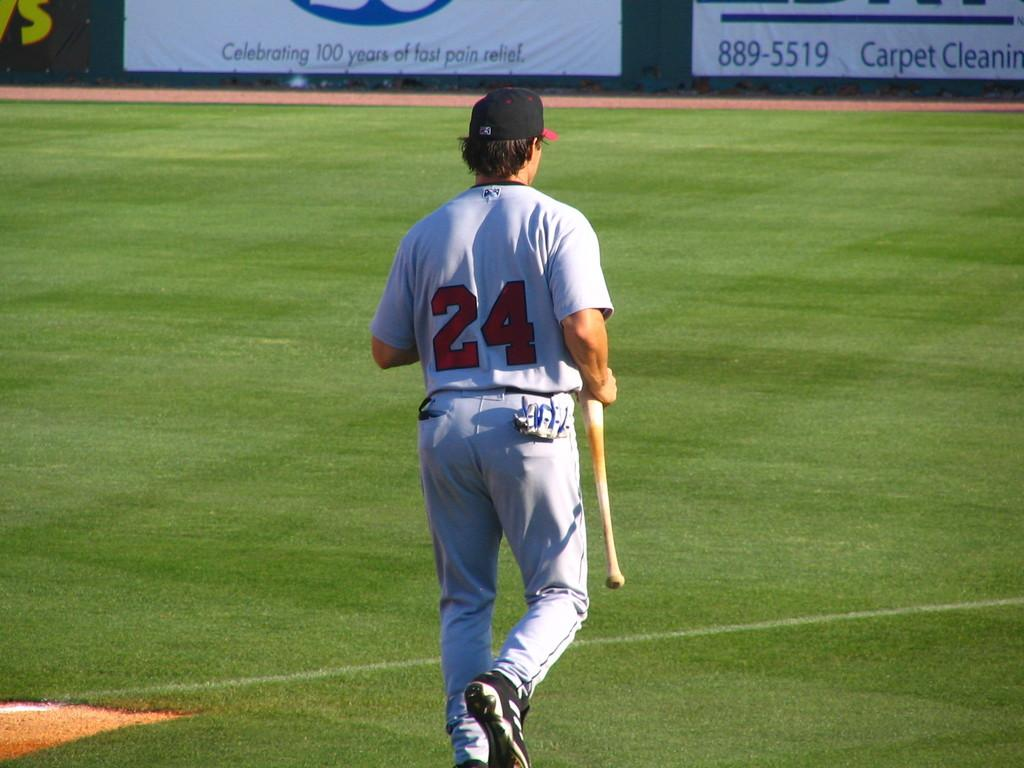<image>
Share a concise interpretation of the image provided. A person wearing a jersey with the number 24 walks in a baseball field. 